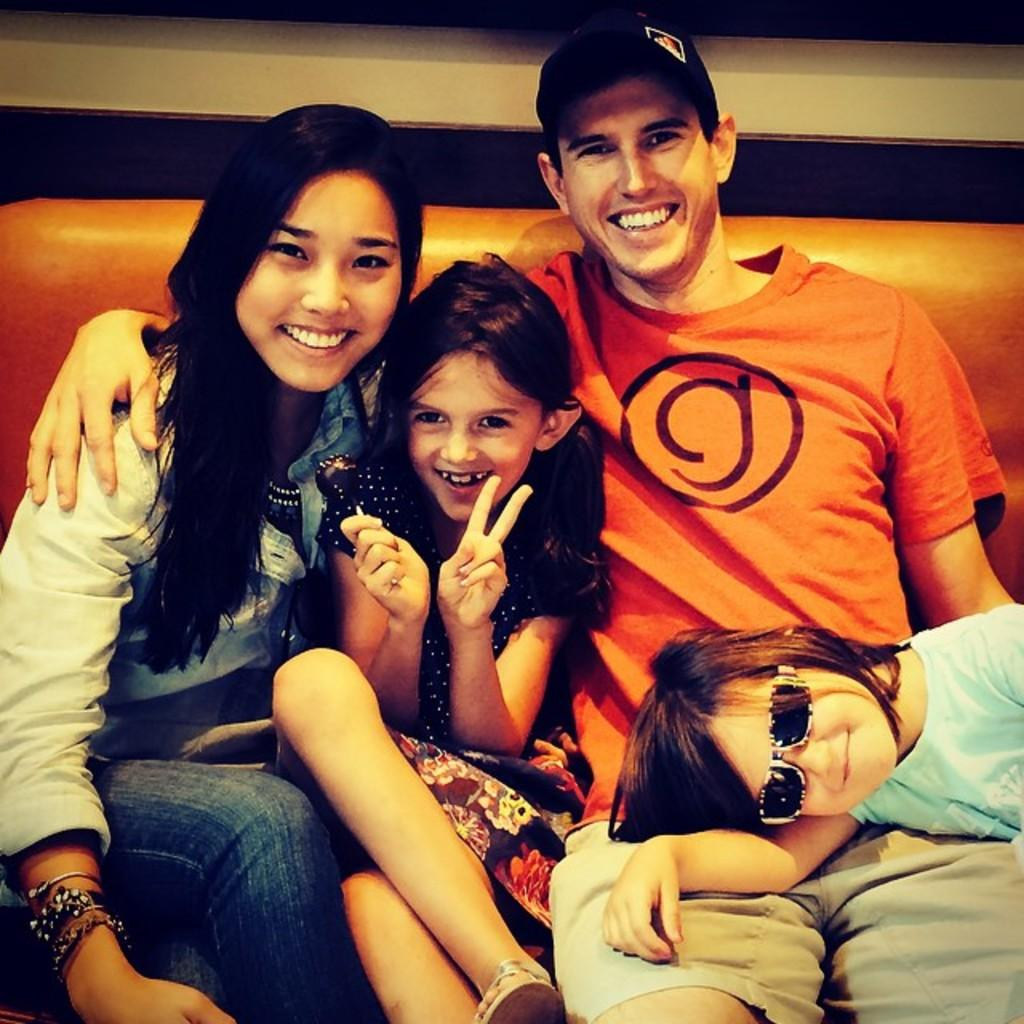How many people are in the image? There are four people in the image, including a man and a woman. What are the man and woman doing in the image? The man and woman are sitting on an orange colored sofa, and they are smiling. What are the children doing in the image? The children are with the man and woman, but their specific actions are not mentioned in the facts. What is the man wearing in the image? The man is wearing an orange T-shirt and a black cap. What country does the man in the image think about the most? There is no information about the man's thoughts or the country he might be thinking about in the image. 